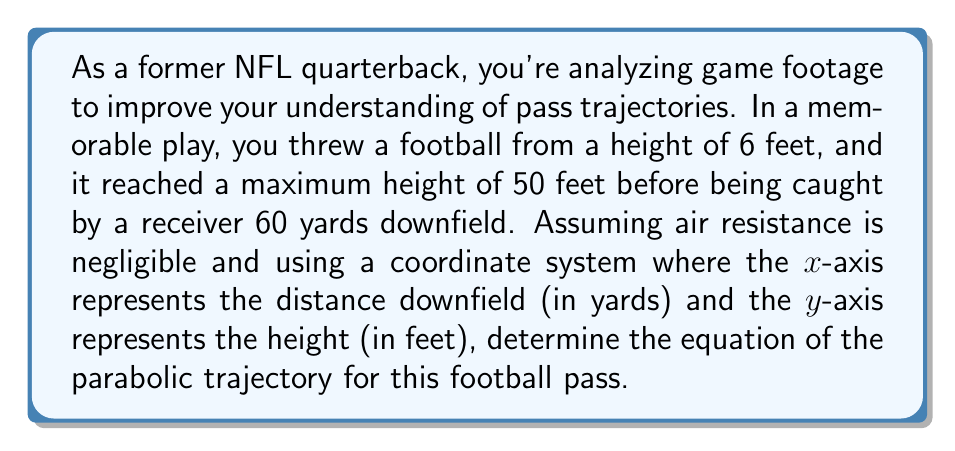What is the answer to this math problem? Let's approach this step-by-step:

1) The general equation of a parabola with a vertical axis of symmetry is:

   $$y = a(x-h)^2 + k$$

   where $(h,k)$ is the vertex of the parabola.

2) We know three points on this parabola:
   - The starting point: $(0, 6)$
   - The vertex (highest point): $(30, 50)$ (assuming the highest point is halfway between start and end)
   - The ending point: $(60, 6)$

3) We can use the vertex form of the parabola equation, as we know the vertex $(h,k) = (30, 50)$:

   $$y = a(x-30)^2 + 50$$

4) To find $a$, we can use either the starting or ending point. Let's use the starting point $(0, 6)$:

   $$6 = a(0-30)^2 + 50$$
   $$6 = 900a + 50$$
   $$-44 = 900a$$
   $$a = -\frac{44}{900} = -\frac{11}{225}$$

5) Therefore, the equation of the parabolic trajectory is:

   $$y = -\frac{11}{225}(x-30)^2 + 50$$

6) We can verify this equation with the ending point $(60, 6)$:

   $$6 \approx -\frac{11}{225}(60-30)^2 + 50$$
   $$6 \approx -\frac{11}{225}(900) + 50$$
   $$6 \approx -44 + 50 = 6$$

This confirms our equation is correct.
Answer: $$y = -\frac{11}{225}(x-30)^2 + 50$$ 